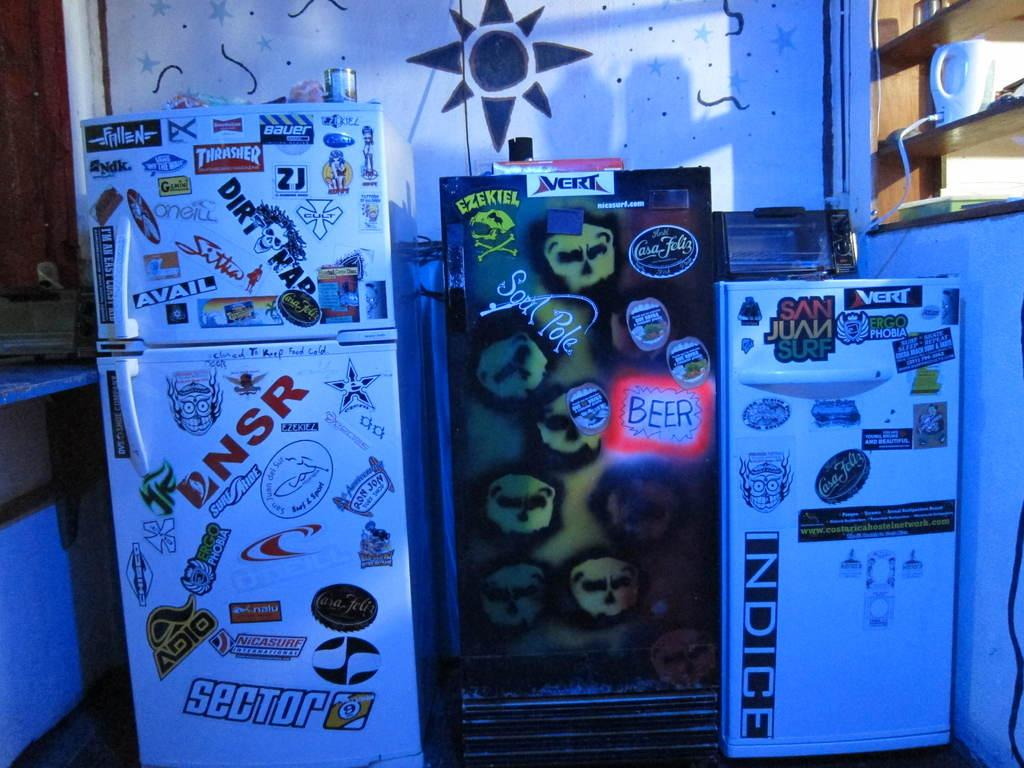<image>
Describe the image concisely. A small fridge has the word INDICE on it, and sits next to two larger fridges. 